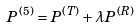Convert formula to latex. <formula><loc_0><loc_0><loc_500><loc_500>P ^ { ( 5 ) } = P ^ { ( T ) } + \lambda P ^ { ( R ) }</formula> 